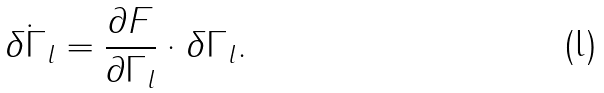Convert formula to latex. <formula><loc_0><loc_0><loc_500><loc_500>\dot { \delta \Gamma _ { l } } = \frac { \partial F } { \partial \Gamma _ { l } } \cdot \delta \Gamma _ { l } .</formula> 